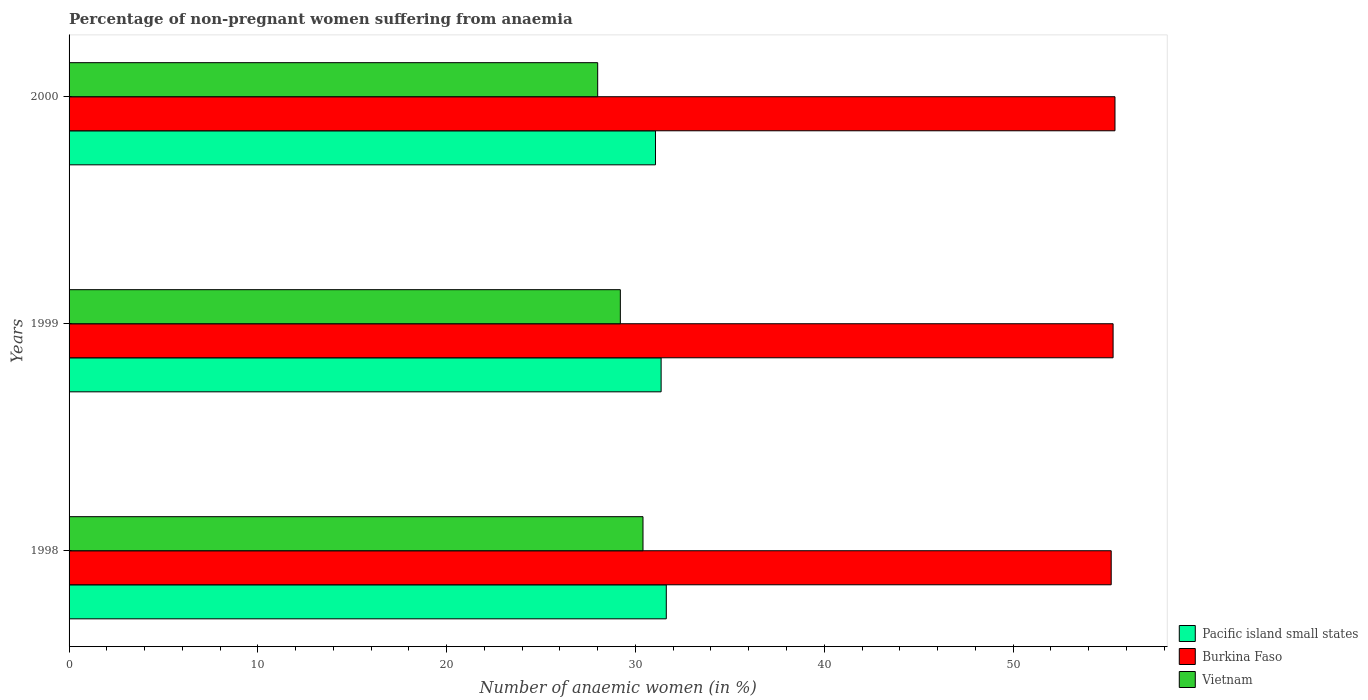How many groups of bars are there?
Your answer should be compact. 3. Are the number of bars on each tick of the Y-axis equal?
Your answer should be compact. Yes. How many bars are there on the 1st tick from the bottom?
Your response must be concise. 3. What is the label of the 1st group of bars from the top?
Your response must be concise. 2000. In how many cases, is the number of bars for a given year not equal to the number of legend labels?
Give a very brief answer. 0. What is the percentage of non-pregnant women suffering from anaemia in Burkina Faso in 2000?
Provide a succinct answer. 55.4. Across all years, what is the maximum percentage of non-pregnant women suffering from anaemia in Pacific island small states?
Provide a short and direct response. 31.63. Across all years, what is the minimum percentage of non-pregnant women suffering from anaemia in Pacific island small states?
Provide a succinct answer. 31.06. In which year was the percentage of non-pregnant women suffering from anaemia in Vietnam maximum?
Provide a short and direct response. 1998. What is the total percentage of non-pregnant women suffering from anaemia in Burkina Faso in the graph?
Your response must be concise. 165.9. What is the difference between the percentage of non-pregnant women suffering from anaemia in Pacific island small states in 1999 and that in 2000?
Ensure brevity in your answer.  0.3. What is the difference between the percentage of non-pregnant women suffering from anaemia in Vietnam in 1998 and the percentage of non-pregnant women suffering from anaemia in Pacific island small states in 1999?
Your answer should be very brief. -0.96. What is the average percentage of non-pregnant women suffering from anaemia in Burkina Faso per year?
Give a very brief answer. 55.3. In the year 1999, what is the difference between the percentage of non-pregnant women suffering from anaemia in Burkina Faso and percentage of non-pregnant women suffering from anaemia in Vietnam?
Your answer should be very brief. 26.1. In how many years, is the percentage of non-pregnant women suffering from anaemia in Vietnam greater than 26 %?
Give a very brief answer. 3. What is the ratio of the percentage of non-pregnant women suffering from anaemia in Pacific island small states in 1998 to that in 2000?
Offer a terse response. 1.02. Is the difference between the percentage of non-pregnant women suffering from anaemia in Burkina Faso in 1999 and 2000 greater than the difference between the percentage of non-pregnant women suffering from anaemia in Vietnam in 1999 and 2000?
Offer a terse response. No. What is the difference between the highest and the second highest percentage of non-pregnant women suffering from anaemia in Pacific island small states?
Offer a terse response. 0.27. What is the difference between the highest and the lowest percentage of non-pregnant women suffering from anaemia in Burkina Faso?
Ensure brevity in your answer.  0.2. In how many years, is the percentage of non-pregnant women suffering from anaemia in Vietnam greater than the average percentage of non-pregnant women suffering from anaemia in Vietnam taken over all years?
Your answer should be compact. 1. Is the sum of the percentage of non-pregnant women suffering from anaemia in Pacific island small states in 1998 and 2000 greater than the maximum percentage of non-pregnant women suffering from anaemia in Vietnam across all years?
Make the answer very short. Yes. What does the 3rd bar from the top in 1998 represents?
Ensure brevity in your answer.  Pacific island small states. What does the 1st bar from the bottom in 2000 represents?
Give a very brief answer. Pacific island small states. Are all the bars in the graph horizontal?
Make the answer very short. Yes. Where does the legend appear in the graph?
Your answer should be very brief. Bottom right. How are the legend labels stacked?
Make the answer very short. Vertical. What is the title of the graph?
Keep it short and to the point. Percentage of non-pregnant women suffering from anaemia. What is the label or title of the X-axis?
Make the answer very short. Number of anaemic women (in %). What is the Number of anaemic women (in %) of Pacific island small states in 1998?
Keep it short and to the point. 31.63. What is the Number of anaemic women (in %) in Burkina Faso in 1998?
Your answer should be very brief. 55.2. What is the Number of anaemic women (in %) in Vietnam in 1998?
Your response must be concise. 30.4. What is the Number of anaemic women (in %) in Pacific island small states in 1999?
Your answer should be very brief. 31.36. What is the Number of anaemic women (in %) of Burkina Faso in 1999?
Your answer should be very brief. 55.3. What is the Number of anaemic women (in %) in Vietnam in 1999?
Provide a succinct answer. 29.2. What is the Number of anaemic women (in %) of Pacific island small states in 2000?
Keep it short and to the point. 31.06. What is the Number of anaemic women (in %) in Burkina Faso in 2000?
Your answer should be very brief. 55.4. Across all years, what is the maximum Number of anaemic women (in %) in Pacific island small states?
Offer a terse response. 31.63. Across all years, what is the maximum Number of anaemic women (in %) of Burkina Faso?
Offer a terse response. 55.4. Across all years, what is the maximum Number of anaemic women (in %) in Vietnam?
Offer a very short reply. 30.4. Across all years, what is the minimum Number of anaemic women (in %) of Pacific island small states?
Offer a terse response. 31.06. Across all years, what is the minimum Number of anaemic women (in %) in Burkina Faso?
Ensure brevity in your answer.  55.2. What is the total Number of anaemic women (in %) of Pacific island small states in the graph?
Your answer should be compact. 94.06. What is the total Number of anaemic women (in %) of Burkina Faso in the graph?
Your response must be concise. 165.9. What is the total Number of anaemic women (in %) in Vietnam in the graph?
Your answer should be compact. 87.6. What is the difference between the Number of anaemic women (in %) in Pacific island small states in 1998 and that in 1999?
Provide a succinct answer. 0.27. What is the difference between the Number of anaemic women (in %) in Pacific island small states in 1998 and that in 2000?
Your response must be concise. 0.57. What is the difference between the Number of anaemic women (in %) of Burkina Faso in 1998 and that in 2000?
Make the answer very short. -0.2. What is the difference between the Number of anaemic women (in %) of Vietnam in 1998 and that in 2000?
Ensure brevity in your answer.  2.4. What is the difference between the Number of anaemic women (in %) of Pacific island small states in 1999 and that in 2000?
Ensure brevity in your answer.  0.3. What is the difference between the Number of anaemic women (in %) of Burkina Faso in 1999 and that in 2000?
Offer a very short reply. -0.1. What is the difference between the Number of anaemic women (in %) of Pacific island small states in 1998 and the Number of anaemic women (in %) of Burkina Faso in 1999?
Ensure brevity in your answer.  -23.67. What is the difference between the Number of anaemic women (in %) in Pacific island small states in 1998 and the Number of anaemic women (in %) in Vietnam in 1999?
Provide a short and direct response. 2.43. What is the difference between the Number of anaemic women (in %) in Pacific island small states in 1998 and the Number of anaemic women (in %) in Burkina Faso in 2000?
Make the answer very short. -23.77. What is the difference between the Number of anaemic women (in %) of Pacific island small states in 1998 and the Number of anaemic women (in %) of Vietnam in 2000?
Your answer should be very brief. 3.63. What is the difference between the Number of anaemic women (in %) of Burkina Faso in 1998 and the Number of anaemic women (in %) of Vietnam in 2000?
Provide a succinct answer. 27.2. What is the difference between the Number of anaemic women (in %) in Pacific island small states in 1999 and the Number of anaemic women (in %) in Burkina Faso in 2000?
Keep it short and to the point. -24.04. What is the difference between the Number of anaemic women (in %) of Pacific island small states in 1999 and the Number of anaemic women (in %) of Vietnam in 2000?
Ensure brevity in your answer.  3.36. What is the difference between the Number of anaemic women (in %) of Burkina Faso in 1999 and the Number of anaemic women (in %) of Vietnam in 2000?
Your answer should be compact. 27.3. What is the average Number of anaemic women (in %) of Pacific island small states per year?
Your response must be concise. 31.35. What is the average Number of anaemic women (in %) of Burkina Faso per year?
Keep it short and to the point. 55.3. What is the average Number of anaemic women (in %) in Vietnam per year?
Offer a terse response. 29.2. In the year 1998, what is the difference between the Number of anaemic women (in %) of Pacific island small states and Number of anaemic women (in %) of Burkina Faso?
Provide a succinct answer. -23.57. In the year 1998, what is the difference between the Number of anaemic women (in %) of Pacific island small states and Number of anaemic women (in %) of Vietnam?
Your answer should be very brief. 1.23. In the year 1998, what is the difference between the Number of anaemic women (in %) of Burkina Faso and Number of anaemic women (in %) of Vietnam?
Keep it short and to the point. 24.8. In the year 1999, what is the difference between the Number of anaemic women (in %) in Pacific island small states and Number of anaemic women (in %) in Burkina Faso?
Your answer should be compact. -23.94. In the year 1999, what is the difference between the Number of anaemic women (in %) of Pacific island small states and Number of anaemic women (in %) of Vietnam?
Give a very brief answer. 2.16. In the year 1999, what is the difference between the Number of anaemic women (in %) of Burkina Faso and Number of anaemic women (in %) of Vietnam?
Offer a terse response. 26.1. In the year 2000, what is the difference between the Number of anaemic women (in %) of Pacific island small states and Number of anaemic women (in %) of Burkina Faso?
Your response must be concise. -24.34. In the year 2000, what is the difference between the Number of anaemic women (in %) in Pacific island small states and Number of anaemic women (in %) in Vietnam?
Offer a very short reply. 3.06. In the year 2000, what is the difference between the Number of anaemic women (in %) of Burkina Faso and Number of anaemic women (in %) of Vietnam?
Offer a very short reply. 27.4. What is the ratio of the Number of anaemic women (in %) of Pacific island small states in 1998 to that in 1999?
Your answer should be very brief. 1.01. What is the ratio of the Number of anaemic women (in %) in Burkina Faso in 1998 to that in 1999?
Your response must be concise. 1. What is the ratio of the Number of anaemic women (in %) in Vietnam in 1998 to that in 1999?
Provide a short and direct response. 1.04. What is the ratio of the Number of anaemic women (in %) of Pacific island small states in 1998 to that in 2000?
Offer a terse response. 1.02. What is the ratio of the Number of anaemic women (in %) of Vietnam in 1998 to that in 2000?
Your response must be concise. 1.09. What is the ratio of the Number of anaemic women (in %) in Pacific island small states in 1999 to that in 2000?
Provide a succinct answer. 1.01. What is the ratio of the Number of anaemic women (in %) of Burkina Faso in 1999 to that in 2000?
Ensure brevity in your answer.  1. What is the ratio of the Number of anaemic women (in %) in Vietnam in 1999 to that in 2000?
Offer a very short reply. 1.04. What is the difference between the highest and the second highest Number of anaemic women (in %) in Pacific island small states?
Keep it short and to the point. 0.27. What is the difference between the highest and the second highest Number of anaemic women (in %) of Burkina Faso?
Provide a succinct answer. 0.1. What is the difference between the highest and the lowest Number of anaemic women (in %) in Pacific island small states?
Keep it short and to the point. 0.57. What is the difference between the highest and the lowest Number of anaemic women (in %) in Burkina Faso?
Your response must be concise. 0.2. What is the difference between the highest and the lowest Number of anaemic women (in %) in Vietnam?
Offer a terse response. 2.4. 